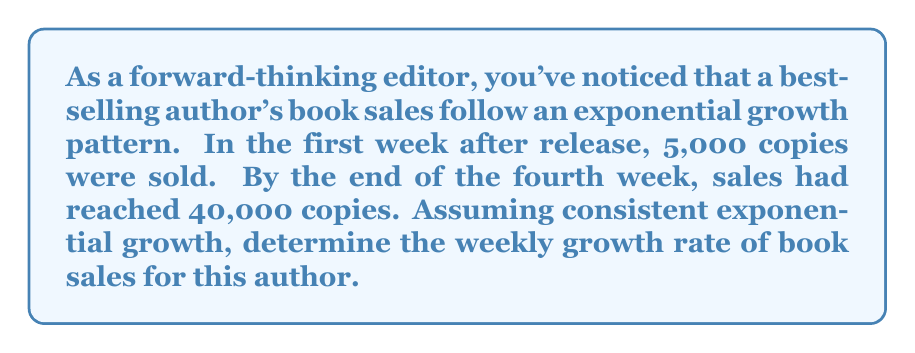Can you answer this question? Let's approach this step-by-step using the exponential growth formula:

$$A = P(1 + r)^t$$

Where:
$A$ = Final amount
$P$ = Initial amount
$r$ = Growth rate (as a decimal)
$t$ = Time period

1) We know:
   $P = 5,000$ (initial sales)
   $A = 40,000$ (sales after 4 weeks)
   $t = 4$ (weeks)

2) Plug these values into the formula:

   $$40,000 = 5,000(1 + r)^4$$

3) Divide both sides by 5,000:

   $$8 = (1 + r)^4$$

4) Take the fourth root of both sides:

   $$\sqrt[4]{8} = 1 + r$$

5) Simplify:

   $$\sqrt[4]{8} = 2^{\frac{4}{4}} = 2^1 = 2$$

   $$2 = 1 + r$$

6) Solve for $r$:

   $$r = 2 - 1 = 1$$

7) Convert to a percentage:

   $$r = 1 = 100\%$$

This growth rate represents a doubling of sales each week, which is an impressive performance for a bestselling author.
Answer: The weekly growth rate of book sales for this bestselling author is 100%. 